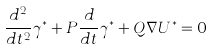<formula> <loc_0><loc_0><loc_500><loc_500>\frac { d ^ { 2 } } { d t ^ { 2 } } \gamma ^ { \ast } + P \frac { d } { d t } \gamma ^ { \ast } + Q \nabla U ^ { \ast } = 0</formula> 